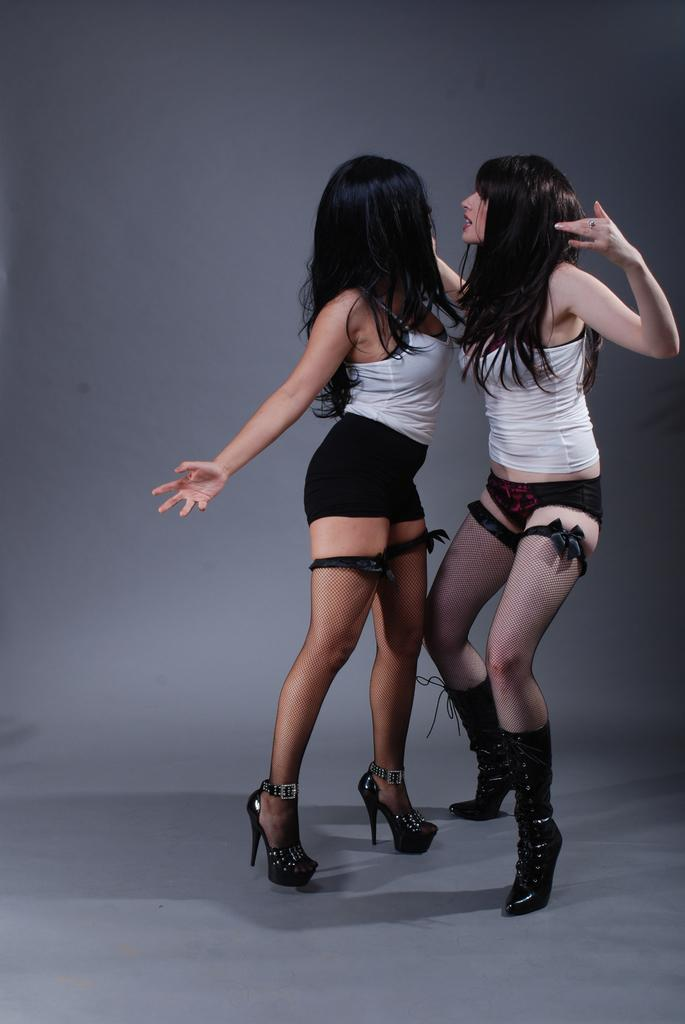How many people are in the image? There are two girls in the image. What are the girls doing in the image? The girls are standing opposite to each other. What can be seen in the background of the image? There is a wall in the background of the image. What street can be seen in the image? There is no street visible in the image; it only shows two girls standing opposite each other with a wall in the background. 